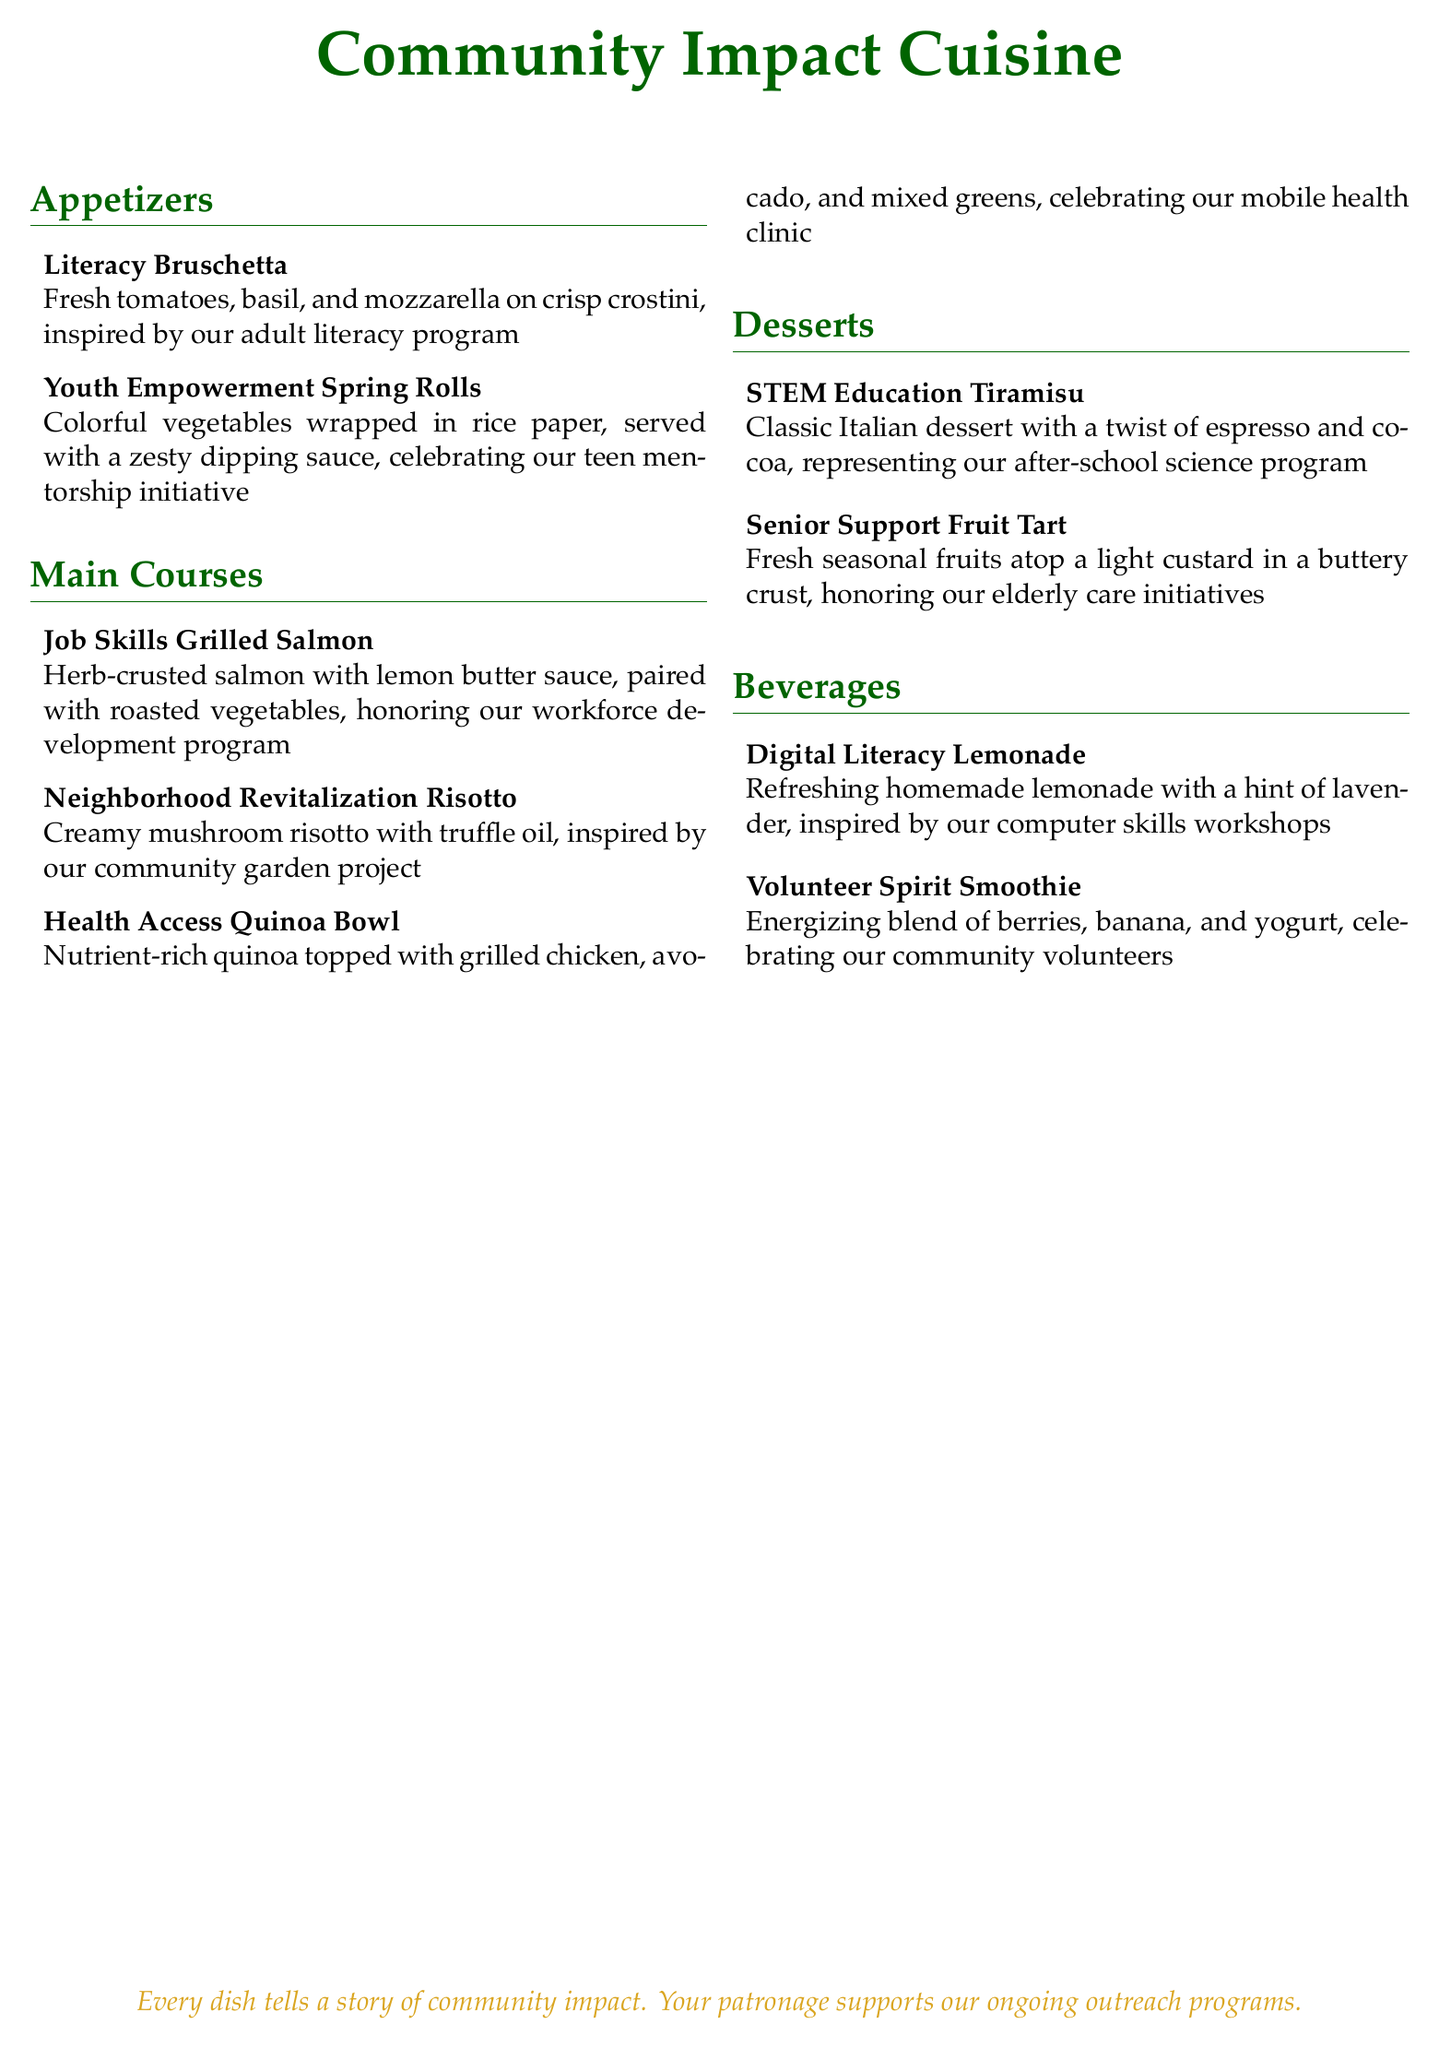What is the name of the appetizer inspired by the adult literacy program? The name of the appetizer is explicitly listed as 'Literacy Bruschetta', which is inspired by the adult literacy program.
Answer: Literacy Bruschetta How many main courses are listed in the menu? The number of main courses can be counted directly from the document, which states there are three main courses.
Answer: 3 What dish honors the elderly care initiatives? The dish that honors the elderly care initiatives is named in the desserts section as 'Senior Support Fruit Tart'.
Answer: Senior Support Fruit Tart Which beverage is inspired by the computer skills workshops? The beverage inspired by the computer skills workshops is titled 'Digital Literacy Lemonade'.
Answer: Digital Literacy Lemonade What is the main ingredient in the 'Health Access Quinoa Bowl'? The main ingredient of the 'Health Access Quinoa Bowl' is the quinoa, as noted in the description of the dish.
Answer: Quinoa What thematic concept do all dishes represent in this menu? All dishes represent the thematic concept of community impact as indicated at the top and within the descriptions of the dishes.
Answer: Community impact What type of cuisine is the 'STEM Education Tiramisu'? The 'STEM Education Tiramisu' is categorized as a classic Italian dessert.
Answer: Italian dessert Which dish celebrates community volunteers? The dish that celebrates community volunteers is named 'Volunteer Spirit Smoothie'.
Answer: Volunteer Spirit Smoothie 